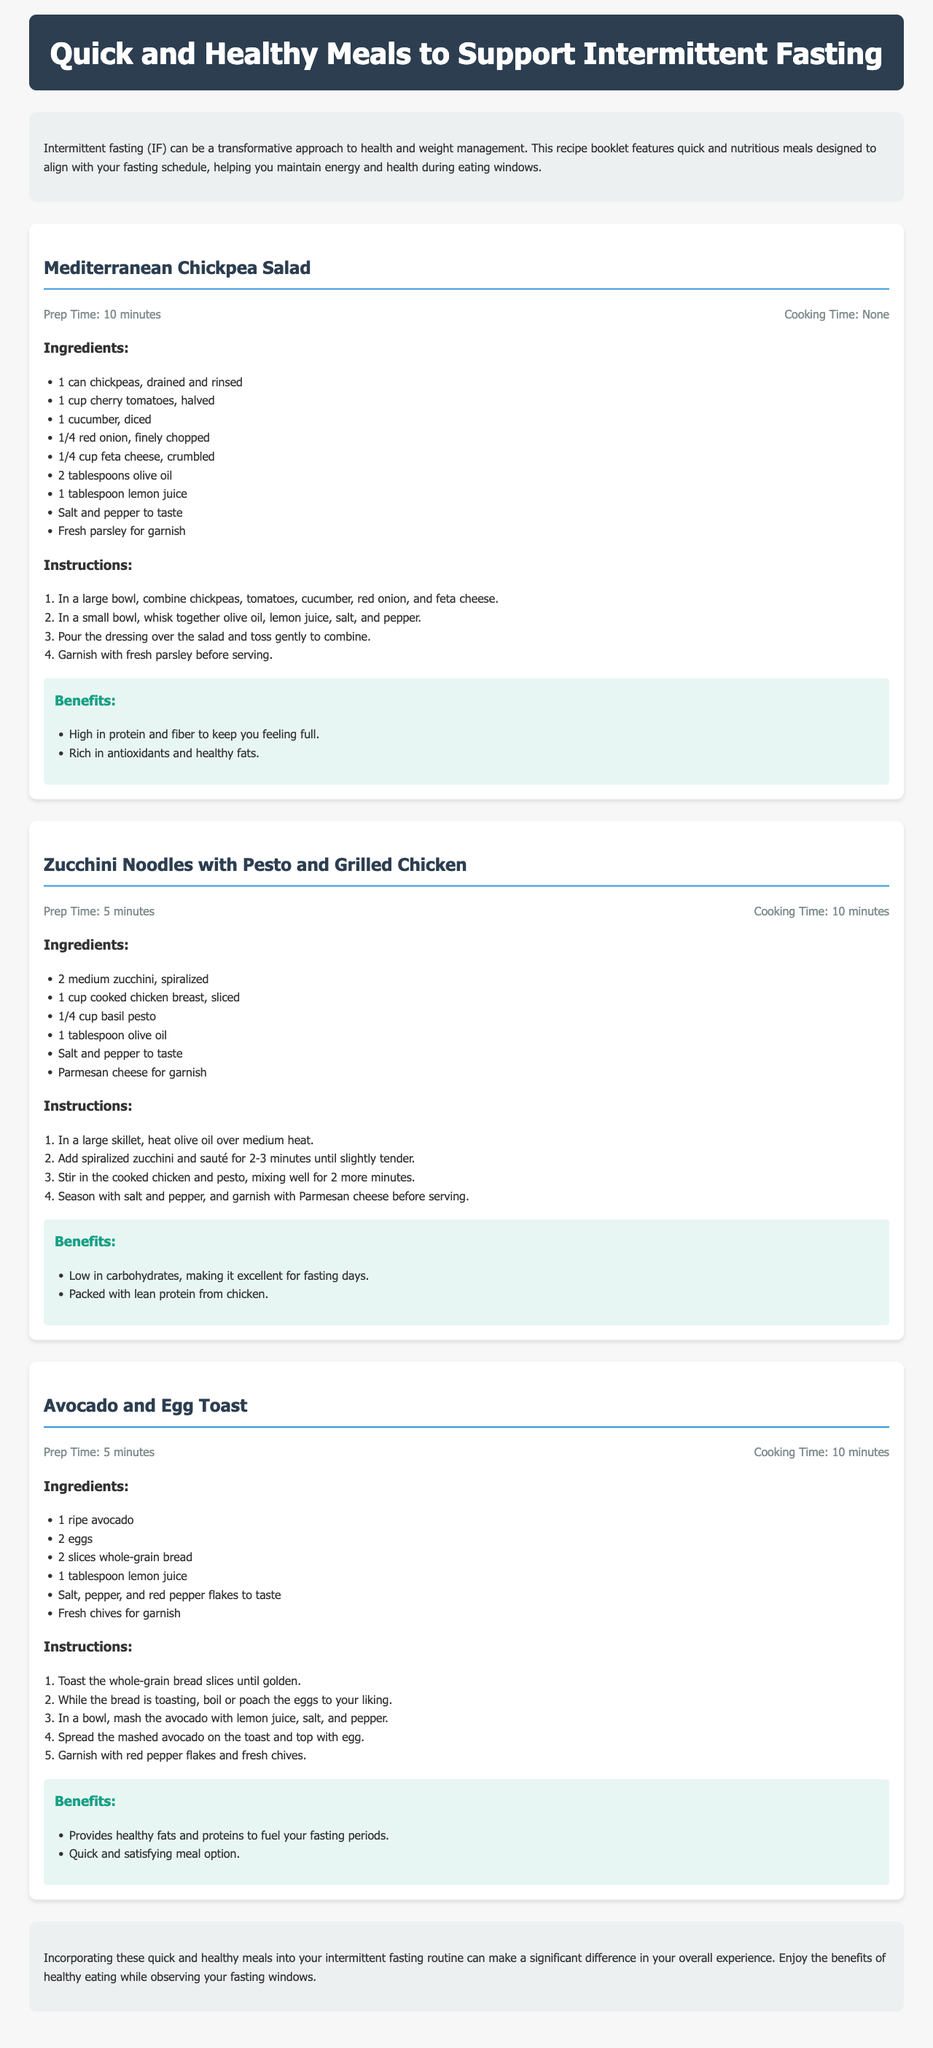What is the title of the document? The title is prominently displayed in the header section of the document.
Answer: Quick and Healthy Meals to Support Intermittent Fasting How many minutes does it take to prepare the Mediterranean Chickpea Salad? The preparation time for this salad is listed in the meal section.
Answer: 10 minutes What is one of the benefits of the Avocado and Egg Toast? Benefits are discussed within each meal section, highlighting nutritional advantages.
Answer: Provides healthy fats and proteins to fuel your fasting periods What ingredient is common in the Zucchini Noodles with Pesto and Grilled Chicken meal? Common ingredients can be identified by analyzing listed components.
Answer: Olive oil How long is the cooking time for Zucchini Noodles with Pesto and Grilled Chicken? The cooking time is specified in the meal section for each recipe.
Answer: 10 minutes What is one key feature of the Mediterranean Chickpea Salad? The benefits section provides specific features regarding nutritional content and health impact.
Answer: High in protein and fiber to keep you feeling full What type of recipe is this document presenting? This question focuses on the general theme of the document.
Answer: Quick and healthy meals How does the document conclude? The conclusion summarizes the purpose and benefits discussed throughout the document.
Answer: Enjoy the benefits of healthy eating while observing your fasting windows 